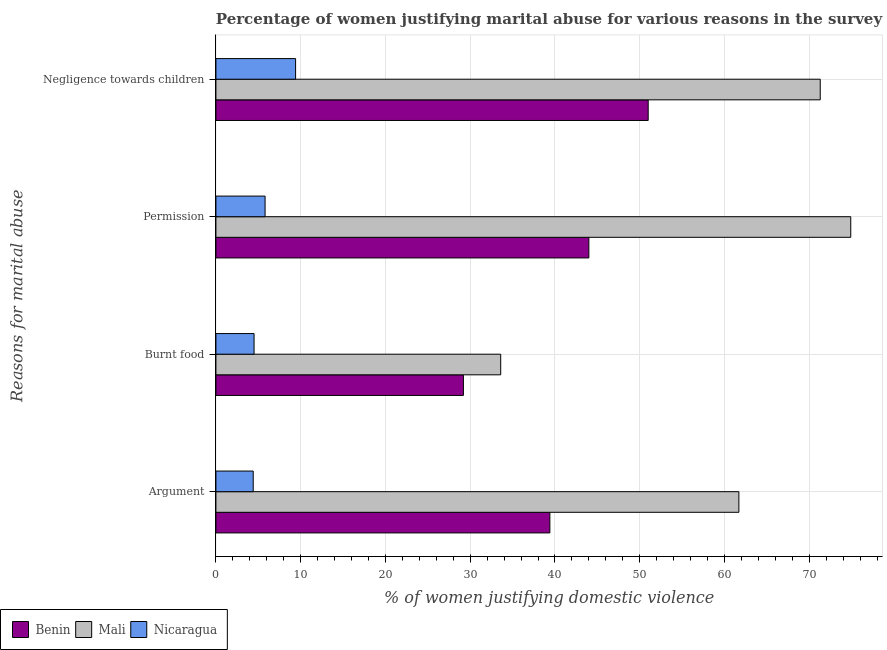How many groups of bars are there?
Offer a very short reply. 4. Are the number of bars on each tick of the Y-axis equal?
Provide a succinct answer. Yes. What is the label of the 1st group of bars from the top?
Make the answer very short. Negligence towards children. What is the percentage of women justifying abuse in the case of an argument in Nicaragua?
Your answer should be very brief. 4.4. Across all countries, what is the maximum percentage of women justifying abuse for burning food?
Offer a terse response. 33.6. In which country was the percentage of women justifying abuse for burning food maximum?
Keep it short and to the point. Mali. In which country was the percentage of women justifying abuse for going without permission minimum?
Provide a short and direct response. Nicaragua. What is the total percentage of women justifying abuse for burning food in the graph?
Your response must be concise. 67.3. What is the difference between the percentage of women justifying abuse for burning food in Nicaragua and that in Mali?
Your response must be concise. -29.1. What is the difference between the percentage of women justifying abuse for showing negligence towards children in Benin and the percentage of women justifying abuse for burning food in Nicaragua?
Your answer should be compact. 46.5. What is the average percentage of women justifying abuse in the case of an argument per country?
Provide a short and direct response. 35.17. In how many countries, is the percentage of women justifying abuse in the case of an argument greater than 10 %?
Provide a short and direct response. 2. What is the ratio of the percentage of women justifying abuse for showing negligence towards children in Mali to that in Nicaragua?
Your response must be concise. 7.59. What is the difference between the highest and the second highest percentage of women justifying abuse for burning food?
Make the answer very short. 4.4. What is the difference between the highest and the lowest percentage of women justifying abuse in the case of an argument?
Your answer should be very brief. 57.3. Is the sum of the percentage of women justifying abuse for going without permission in Benin and Mali greater than the maximum percentage of women justifying abuse for burning food across all countries?
Give a very brief answer. Yes. Is it the case that in every country, the sum of the percentage of women justifying abuse for going without permission and percentage of women justifying abuse for showing negligence towards children is greater than the sum of percentage of women justifying abuse in the case of an argument and percentage of women justifying abuse for burning food?
Keep it short and to the point. No. What does the 3rd bar from the top in Negligence towards children represents?
Your response must be concise. Benin. What does the 1st bar from the bottom in Negligence towards children represents?
Offer a very short reply. Benin. Are all the bars in the graph horizontal?
Ensure brevity in your answer.  Yes. What is the title of the graph?
Your answer should be compact. Percentage of women justifying marital abuse for various reasons in the survey of 2001. What is the label or title of the X-axis?
Your response must be concise. % of women justifying domestic violence. What is the label or title of the Y-axis?
Your answer should be very brief. Reasons for marital abuse. What is the % of women justifying domestic violence of Benin in Argument?
Give a very brief answer. 39.4. What is the % of women justifying domestic violence of Mali in Argument?
Offer a very short reply. 61.7. What is the % of women justifying domestic violence in Benin in Burnt food?
Ensure brevity in your answer.  29.2. What is the % of women justifying domestic violence in Mali in Burnt food?
Offer a terse response. 33.6. What is the % of women justifying domestic violence in Benin in Permission?
Give a very brief answer. 44. What is the % of women justifying domestic violence in Mali in Permission?
Offer a very short reply. 74.9. What is the % of women justifying domestic violence of Mali in Negligence towards children?
Provide a succinct answer. 71.3. Across all Reasons for marital abuse, what is the maximum % of women justifying domestic violence in Mali?
Your response must be concise. 74.9. Across all Reasons for marital abuse, what is the maximum % of women justifying domestic violence in Nicaragua?
Your answer should be compact. 9.4. Across all Reasons for marital abuse, what is the minimum % of women justifying domestic violence in Benin?
Keep it short and to the point. 29.2. Across all Reasons for marital abuse, what is the minimum % of women justifying domestic violence of Mali?
Your answer should be very brief. 33.6. Across all Reasons for marital abuse, what is the minimum % of women justifying domestic violence in Nicaragua?
Offer a terse response. 4.4. What is the total % of women justifying domestic violence in Benin in the graph?
Ensure brevity in your answer.  163.6. What is the total % of women justifying domestic violence in Mali in the graph?
Provide a succinct answer. 241.5. What is the total % of women justifying domestic violence of Nicaragua in the graph?
Your answer should be compact. 24.1. What is the difference between the % of women justifying domestic violence in Mali in Argument and that in Burnt food?
Give a very brief answer. 28.1. What is the difference between the % of women justifying domestic violence of Benin in Argument and that in Permission?
Your answer should be compact. -4.6. What is the difference between the % of women justifying domestic violence of Nicaragua in Argument and that in Permission?
Offer a very short reply. -1.4. What is the difference between the % of women justifying domestic violence in Mali in Argument and that in Negligence towards children?
Provide a succinct answer. -9.6. What is the difference between the % of women justifying domestic violence in Nicaragua in Argument and that in Negligence towards children?
Offer a terse response. -5. What is the difference between the % of women justifying domestic violence of Benin in Burnt food and that in Permission?
Give a very brief answer. -14.8. What is the difference between the % of women justifying domestic violence in Mali in Burnt food and that in Permission?
Your answer should be compact. -41.3. What is the difference between the % of women justifying domestic violence of Nicaragua in Burnt food and that in Permission?
Offer a terse response. -1.3. What is the difference between the % of women justifying domestic violence in Benin in Burnt food and that in Negligence towards children?
Give a very brief answer. -21.8. What is the difference between the % of women justifying domestic violence of Mali in Burnt food and that in Negligence towards children?
Make the answer very short. -37.7. What is the difference between the % of women justifying domestic violence of Nicaragua in Permission and that in Negligence towards children?
Ensure brevity in your answer.  -3.6. What is the difference between the % of women justifying domestic violence in Benin in Argument and the % of women justifying domestic violence in Mali in Burnt food?
Ensure brevity in your answer.  5.8. What is the difference between the % of women justifying domestic violence of Benin in Argument and the % of women justifying domestic violence of Nicaragua in Burnt food?
Make the answer very short. 34.9. What is the difference between the % of women justifying domestic violence in Mali in Argument and the % of women justifying domestic violence in Nicaragua in Burnt food?
Ensure brevity in your answer.  57.2. What is the difference between the % of women justifying domestic violence in Benin in Argument and the % of women justifying domestic violence in Mali in Permission?
Your answer should be very brief. -35.5. What is the difference between the % of women justifying domestic violence in Benin in Argument and the % of women justifying domestic violence in Nicaragua in Permission?
Your response must be concise. 33.6. What is the difference between the % of women justifying domestic violence of Mali in Argument and the % of women justifying domestic violence of Nicaragua in Permission?
Your response must be concise. 55.9. What is the difference between the % of women justifying domestic violence in Benin in Argument and the % of women justifying domestic violence in Mali in Negligence towards children?
Offer a very short reply. -31.9. What is the difference between the % of women justifying domestic violence in Benin in Argument and the % of women justifying domestic violence in Nicaragua in Negligence towards children?
Offer a very short reply. 30. What is the difference between the % of women justifying domestic violence in Mali in Argument and the % of women justifying domestic violence in Nicaragua in Negligence towards children?
Ensure brevity in your answer.  52.3. What is the difference between the % of women justifying domestic violence in Benin in Burnt food and the % of women justifying domestic violence in Mali in Permission?
Offer a terse response. -45.7. What is the difference between the % of women justifying domestic violence in Benin in Burnt food and the % of women justifying domestic violence in Nicaragua in Permission?
Ensure brevity in your answer.  23.4. What is the difference between the % of women justifying domestic violence of Mali in Burnt food and the % of women justifying domestic violence of Nicaragua in Permission?
Offer a very short reply. 27.8. What is the difference between the % of women justifying domestic violence of Benin in Burnt food and the % of women justifying domestic violence of Mali in Negligence towards children?
Provide a succinct answer. -42.1. What is the difference between the % of women justifying domestic violence of Benin in Burnt food and the % of women justifying domestic violence of Nicaragua in Negligence towards children?
Your answer should be very brief. 19.8. What is the difference between the % of women justifying domestic violence in Mali in Burnt food and the % of women justifying domestic violence in Nicaragua in Negligence towards children?
Your answer should be compact. 24.2. What is the difference between the % of women justifying domestic violence in Benin in Permission and the % of women justifying domestic violence in Mali in Negligence towards children?
Your response must be concise. -27.3. What is the difference between the % of women justifying domestic violence of Benin in Permission and the % of women justifying domestic violence of Nicaragua in Negligence towards children?
Offer a very short reply. 34.6. What is the difference between the % of women justifying domestic violence of Mali in Permission and the % of women justifying domestic violence of Nicaragua in Negligence towards children?
Offer a very short reply. 65.5. What is the average % of women justifying domestic violence in Benin per Reasons for marital abuse?
Your response must be concise. 40.9. What is the average % of women justifying domestic violence of Mali per Reasons for marital abuse?
Ensure brevity in your answer.  60.38. What is the average % of women justifying domestic violence in Nicaragua per Reasons for marital abuse?
Give a very brief answer. 6.03. What is the difference between the % of women justifying domestic violence of Benin and % of women justifying domestic violence of Mali in Argument?
Provide a short and direct response. -22.3. What is the difference between the % of women justifying domestic violence in Mali and % of women justifying domestic violence in Nicaragua in Argument?
Give a very brief answer. 57.3. What is the difference between the % of women justifying domestic violence of Benin and % of women justifying domestic violence of Nicaragua in Burnt food?
Your response must be concise. 24.7. What is the difference between the % of women justifying domestic violence in Mali and % of women justifying domestic violence in Nicaragua in Burnt food?
Make the answer very short. 29.1. What is the difference between the % of women justifying domestic violence of Benin and % of women justifying domestic violence of Mali in Permission?
Keep it short and to the point. -30.9. What is the difference between the % of women justifying domestic violence in Benin and % of women justifying domestic violence in Nicaragua in Permission?
Offer a terse response. 38.2. What is the difference between the % of women justifying domestic violence of Mali and % of women justifying domestic violence of Nicaragua in Permission?
Provide a succinct answer. 69.1. What is the difference between the % of women justifying domestic violence of Benin and % of women justifying domestic violence of Mali in Negligence towards children?
Provide a short and direct response. -20.3. What is the difference between the % of women justifying domestic violence of Benin and % of women justifying domestic violence of Nicaragua in Negligence towards children?
Offer a terse response. 41.6. What is the difference between the % of women justifying domestic violence in Mali and % of women justifying domestic violence in Nicaragua in Negligence towards children?
Ensure brevity in your answer.  61.9. What is the ratio of the % of women justifying domestic violence in Benin in Argument to that in Burnt food?
Ensure brevity in your answer.  1.35. What is the ratio of the % of women justifying domestic violence of Mali in Argument to that in Burnt food?
Keep it short and to the point. 1.84. What is the ratio of the % of women justifying domestic violence of Nicaragua in Argument to that in Burnt food?
Offer a very short reply. 0.98. What is the ratio of the % of women justifying domestic violence in Benin in Argument to that in Permission?
Give a very brief answer. 0.9. What is the ratio of the % of women justifying domestic violence in Mali in Argument to that in Permission?
Your answer should be compact. 0.82. What is the ratio of the % of women justifying domestic violence of Nicaragua in Argument to that in Permission?
Your answer should be very brief. 0.76. What is the ratio of the % of women justifying domestic violence in Benin in Argument to that in Negligence towards children?
Your answer should be very brief. 0.77. What is the ratio of the % of women justifying domestic violence of Mali in Argument to that in Negligence towards children?
Give a very brief answer. 0.87. What is the ratio of the % of women justifying domestic violence of Nicaragua in Argument to that in Negligence towards children?
Offer a terse response. 0.47. What is the ratio of the % of women justifying domestic violence of Benin in Burnt food to that in Permission?
Offer a very short reply. 0.66. What is the ratio of the % of women justifying domestic violence in Mali in Burnt food to that in Permission?
Your answer should be compact. 0.45. What is the ratio of the % of women justifying domestic violence in Nicaragua in Burnt food to that in Permission?
Offer a terse response. 0.78. What is the ratio of the % of women justifying domestic violence of Benin in Burnt food to that in Negligence towards children?
Offer a very short reply. 0.57. What is the ratio of the % of women justifying domestic violence in Mali in Burnt food to that in Negligence towards children?
Offer a very short reply. 0.47. What is the ratio of the % of women justifying domestic violence in Nicaragua in Burnt food to that in Negligence towards children?
Provide a succinct answer. 0.48. What is the ratio of the % of women justifying domestic violence of Benin in Permission to that in Negligence towards children?
Provide a succinct answer. 0.86. What is the ratio of the % of women justifying domestic violence in Mali in Permission to that in Negligence towards children?
Your answer should be very brief. 1.05. What is the ratio of the % of women justifying domestic violence of Nicaragua in Permission to that in Negligence towards children?
Make the answer very short. 0.62. What is the difference between the highest and the second highest % of women justifying domestic violence of Mali?
Keep it short and to the point. 3.6. What is the difference between the highest and the second highest % of women justifying domestic violence of Nicaragua?
Your answer should be compact. 3.6. What is the difference between the highest and the lowest % of women justifying domestic violence of Benin?
Offer a very short reply. 21.8. What is the difference between the highest and the lowest % of women justifying domestic violence of Mali?
Provide a short and direct response. 41.3. What is the difference between the highest and the lowest % of women justifying domestic violence of Nicaragua?
Your response must be concise. 5. 